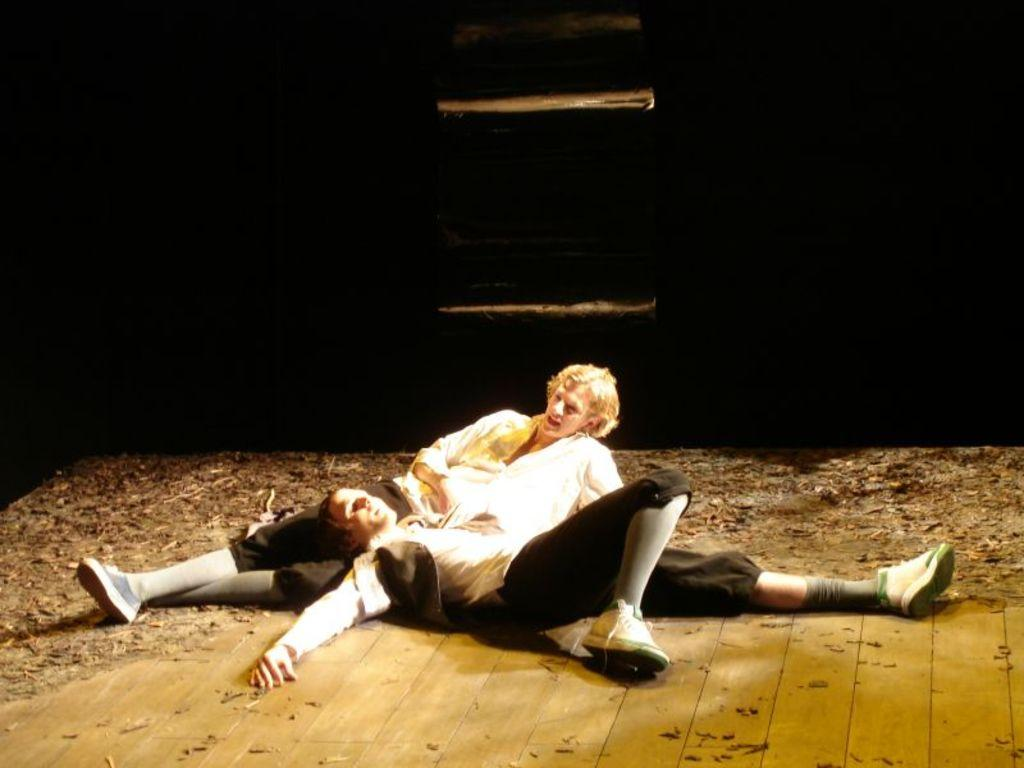How many people are in the image? There are two persons lying down in the image. What is present at the bottom of the image? There is sawdust at the bottom of the image. What can be observed about the lighting in the image? The background of the image is dark. What type of growth can be seen on the persons in the image? There is no growth visible on the persons in the image. What is the interest of the persons in the image? The image does not provide information about the interests of the persons. What belief is shared by the persons in the image? The image does not provide information about the beliefs of the persons. 